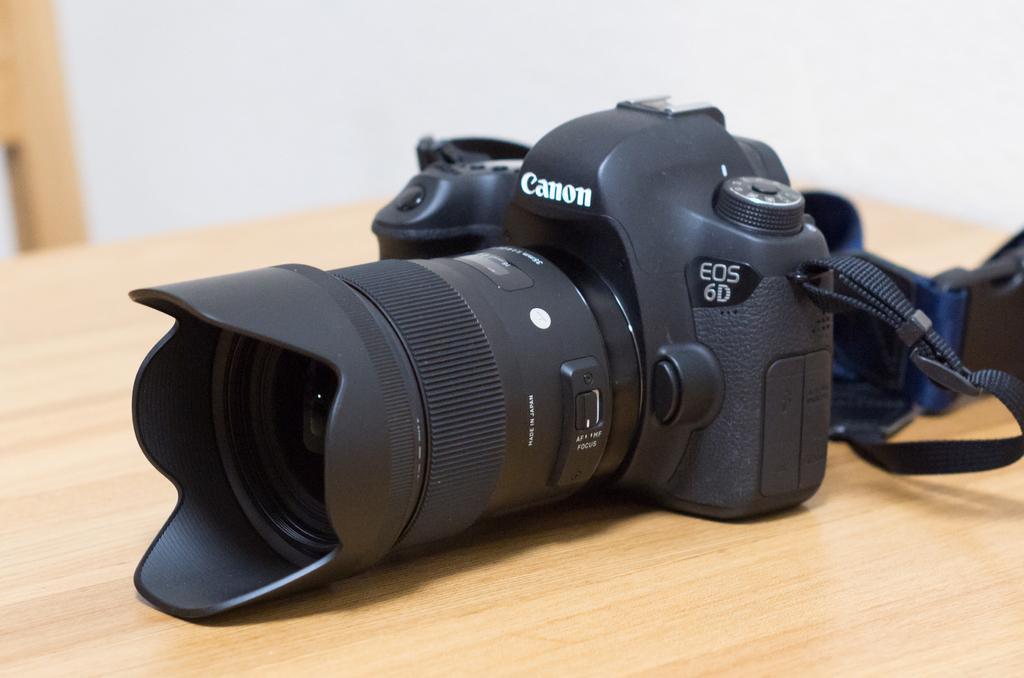Could you give a brief overview of what you see in this image? In this picture we can see a camera on the table and in the background we can see an object and the wall. 